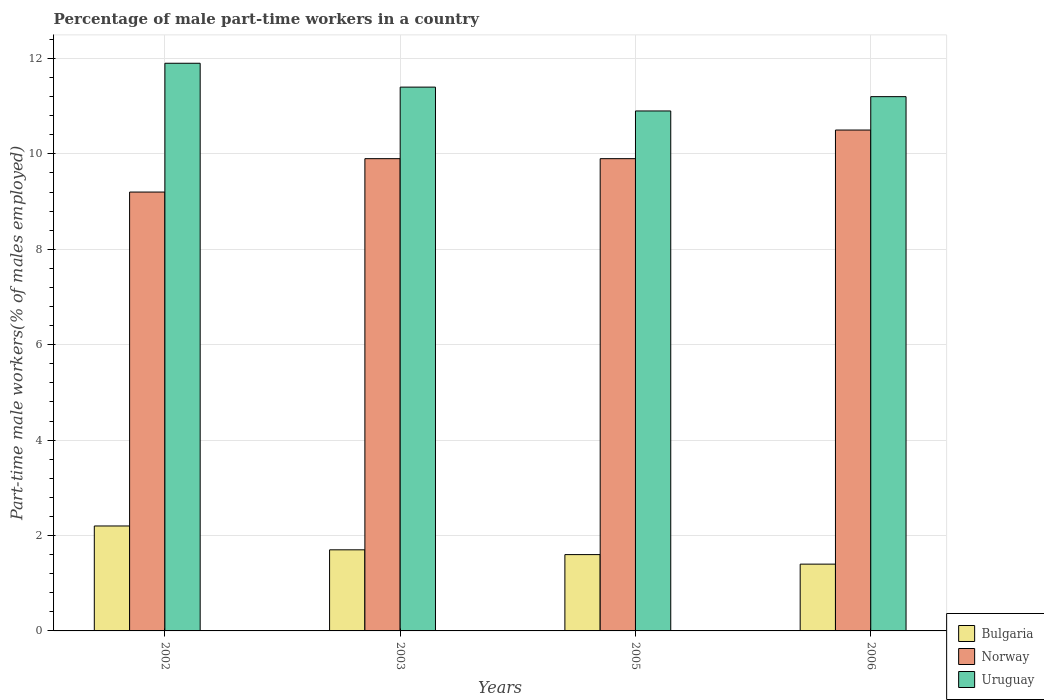Are the number of bars per tick equal to the number of legend labels?
Keep it short and to the point. Yes. Are the number of bars on each tick of the X-axis equal?
Offer a terse response. Yes. How many bars are there on the 4th tick from the left?
Ensure brevity in your answer.  3. What is the percentage of male part-time workers in Uruguay in 2002?
Give a very brief answer. 11.9. Across all years, what is the maximum percentage of male part-time workers in Uruguay?
Offer a very short reply. 11.9. Across all years, what is the minimum percentage of male part-time workers in Bulgaria?
Provide a short and direct response. 1.4. What is the total percentage of male part-time workers in Uruguay in the graph?
Your answer should be compact. 45.4. What is the difference between the percentage of male part-time workers in Norway in 2002 and that in 2003?
Provide a short and direct response. -0.7. What is the difference between the percentage of male part-time workers in Uruguay in 2003 and the percentage of male part-time workers in Norway in 2005?
Keep it short and to the point. 1.5. What is the average percentage of male part-time workers in Uruguay per year?
Give a very brief answer. 11.35. In the year 2003, what is the difference between the percentage of male part-time workers in Uruguay and percentage of male part-time workers in Norway?
Your answer should be compact. 1.5. What is the ratio of the percentage of male part-time workers in Uruguay in 2003 to that in 2006?
Your answer should be very brief. 1.02. Is the percentage of male part-time workers in Bulgaria in 2002 less than that in 2006?
Offer a very short reply. No. Is the difference between the percentage of male part-time workers in Uruguay in 2005 and 2006 greater than the difference between the percentage of male part-time workers in Norway in 2005 and 2006?
Provide a succinct answer. Yes. What is the difference between the highest and the lowest percentage of male part-time workers in Bulgaria?
Your answer should be compact. 0.8. Is the sum of the percentage of male part-time workers in Bulgaria in 2002 and 2006 greater than the maximum percentage of male part-time workers in Norway across all years?
Make the answer very short. No. What does the 3rd bar from the left in 2005 represents?
Make the answer very short. Uruguay. How many bars are there?
Keep it short and to the point. 12. How many years are there in the graph?
Give a very brief answer. 4. What is the difference between two consecutive major ticks on the Y-axis?
Give a very brief answer. 2. Are the values on the major ticks of Y-axis written in scientific E-notation?
Your response must be concise. No. Does the graph contain grids?
Your response must be concise. Yes. Where does the legend appear in the graph?
Your answer should be very brief. Bottom right. How many legend labels are there?
Offer a terse response. 3. What is the title of the graph?
Your answer should be very brief. Percentage of male part-time workers in a country. Does "Arab World" appear as one of the legend labels in the graph?
Make the answer very short. No. What is the label or title of the Y-axis?
Give a very brief answer. Part-time male workers(% of males employed). What is the Part-time male workers(% of males employed) of Bulgaria in 2002?
Provide a short and direct response. 2.2. What is the Part-time male workers(% of males employed) of Norway in 2002?
Offer a very short reply. 9.2. What is the Part-time male workers(% of males employed) of Uruguay in 2002?
Provide a short and direct response. 11.9. What is the Part-time male workers(% of males employed) in Bulgaria in 2003?
Make the answer very short. 1.7. What is the Part-time male workers(% of males employed) of Norway in 2003?
Your answer should be compact. 9.9. What is the Part-time male workers(% of males employed) of Uruguay in 2003?
Ensure brevity in your answer.  11.4. What is the Part-time male workers(% of males employed) in Bulgaria in 2005?
Give a very brief answer. 1.6. What is the Part-time male workers(% of males employed) in Norway in 2005?
Ensure brevity in your answer.  9.9. What is the Part-time male workers(% of males employed) in Uruguay in 2005?
Your response must be concise. 10.9. What is the Part-time male workers(% of males employed) of Bulgaria in 2006?
Ensure brevity in your answer.  1.4. What is the Part-time male workers(% of males employed) in Uruguay in 2006?
Ensure brevity in your answer.  11.2. Across all years, what is the maximum Part-time male workers(% of males employed) in Bulgaria?
Make the answer very short. 2.2. Across all years, what is the maximum Part-time male workers(% of males employed) of Uruguay?
Keep it short and to the point. 11.9. Across all years, what is the minimum Part-time male workers(% of males employed) of Bulgaria?
Your answer should be compact. 1.4. Across all years, what is the minimum Part-time male workers(% of males employed) of Norway?
Your answer should be compact. 9.2. Across all years, what is the minimum Part-time male workers(% of males employed) in Uruguay?
Provide a succinct answer. 10.9. What is the total Part-time male workers(% of males employed) in Bulgaria in the graph?
Offer a very short reply. 6.9. What is the total Part-time male workers(% of males employed) in Norway in the graph?
Ensure brevity in your answer.  39.5. What is the total Part-time male workers(% of males employed) of Uruguay in the graph?
Your response must be concise. 45.4. What is the difference between the Part-time male workers(% of males employed) of Bulgaria in 2002 and that in 2003?
Your answer should be very brief. 0.5. What is the difference between the Part-time male workers(% of males employed) of Norway in 2002 and that in 2003?
Your response must be concise. -0.7. What is the difference between the Part-time male workers(% of males employed) of Uruguay in 2002 and that in 2003?
Keep it short and to the point. 0.5. What is the difference between the Part-time male workers(% of males employed) in Bulgaria in 2002 and that in 2005?
Your answer should be very brief. 0.6. What is the difference between the Part-time male workers(% of males employed) of Norway in 2002 and that in 2005?
Give a very brief answer. -0.7. What is the difference between the Part-time male workers(% of males employed) of Uruguay in 2002 and that in 2005?
Offer a terse response. 1. What is the difference between the Part-time male workers(% of males employed) in Uruguay in 2002 and that in 2006?
Give a very brief answer. 0.7. What is the difference between the Part-time male workers(% of males employed) in Uruguay in 2003 and that in 2005?
Your answer should be compact. 0.5. What is the difference between the Part-time male workers(% of males employed) of Norway in 2003 and that in 2006?
Provide a short and direct response. -0.6. What is the difference between the Part-time male workers(% of males employed) in Uruguay in 2003 and that in 2006?
Give a very brief answer. 0.2. What is the difference between the Part-time male workers(% of males employed) in Bulgaria in 2005 and that in 2006?
Offer a terse response. 0.2. What is the difference between the Part-time male workers(% of males employed) in Uruguay in 2005 and that in 2006?
Your answer should be very brief. -0.3. What is the difference between the Part-time male workers(% of males employed) of Bulgaria in 2002 and the Part-time male workers(% of males employed) of Norway in 2005?
Your answer should be very brief. -7.7. What is the difference between the Part-time male workers(% of males employed) in Norway in 2002 and the Part-time male workers(% of males employed) in Uruguay in 2005?
Your answer should be compact. -1.7. What is the difference between the Part-time male workers(% of males employed) of Bulgaria in 2002 and the Part-time male workers(% of males employed) of Uruguay in 2006?
Make the answer very short. -9. What is the difference between the Part-time male workers(% of males employed) of Bulgaria in 2003 and the Part-time male workers(% of males employed) of Norway in 2005?
Give a very brief answer. -8.2. What is the difference between the Part-time male workers(% of males employed) in Norway in 2003 and the Part-time male workers(% of males employed) in Uruguay in 2005?
Provide a short and direct response. -1. What is the difference between the Part-time male workers(% of males employed) of Bulgaria in 2003 and the Part-time male workers(% of males employed) of Norway in 2006?
Provide a succinct answer. -8.8. What is the difference between the Part-time male workers(% of males employed) in Bulgaria in 2003 and the Part-time male workers(% of males employed) in Uruguay in 2006?
Ensure brevity in your answer.  -9.5. What is the difference between the Part-time male workers(% of males employed) in Bulgaria in 2005 and the Part-time male workers(% of males employed) in Uruguay in 2006?
Your response must be concise. -9.6. What is the difference between the Part-time male workers(% of males employed) in Norway in 2005 and the Part-time male workers(% of males employed) in Uruguay in 2006?
Offer a terse response. -1.3. What is the average Part-time male workers(% of males employed) in Bulgaria per year?
Provide a succinct answer. 1.73. What is the average Part-time male workers(% of males employed) of Norway per year?
Ensure brevity in your answer.  9.88. What is the average Part-time male workers(% of males employed) in Uruguay per year?
Offer a terse response. 11.35. In the year 2002, what is the difference between the Part-time male workers(% of males employed) of Bulgaria and Part-time male workers(% of males employed) of Uruguay?
Your response must be concise. -9.7. In the year 2003, what is the difference between the Part-time male workers(% of males employed) in Bulgaria and Part-time male workers(% of males employed) in Norway?
Your answer should be very brief. -8.2. In the year 2003, what is the difference between the Part-time male workers(% of males employed) in Bulgaria and Part-time male workers(% of males employed) in Uruguay?
Make the answer very short. -9.7. In the year 2005, what is the difference between the Part-time male workers(% of males employed) in Bulgaria and Part-time male workers(% of males employed) in Uruguay?
Make the answer very short. -9.3. In the year 2006, what is the difference between the Part-time male workers(% of males employed) in Bulgaria and Part-time male workers(% of males employed) in Norway?
Make the answer very short. -9.1. What is the ratio of the Part-time male workers(% of males employed) in Bulgaria in 2002 to that in 2003?
Your response must be concise. 1.29. What is the ratio of the Part-time male workers(% of males employed) in Norway in 2002 to that in 2003?
Your answer should be very brief. 0.93. What is the ratio of the Part-time male workers(% of males employed) of Uruguay in 2002 to that in 2003?
Give a very brief answer. 1.04. What is the ratio of the Part-time male workers(% of males employed) of Bulgaria in 2002 to that in 2005?
Give a very brief answer. 1.38. What is the ratio of the Part-time male workers(% of males employed) in Norway in 2002 to that in 2005?
Make the answer very short. 0.93. What is the ratio of the Part-time male workers(% of males employed) in Uruguay in 2002 to that in 2005?
Your answer should be very brief. 1.09. What is the ratio of the Part-time male workers(% of males employed) of Bulgaria in 2002 to that in 2006?
Offer a terse response. 1.57. What is the ratio of the Part-time male workers(% of males employed) of Norway in 2002 to that in 2006?
Offer a very short reply. 0.88. What is the ratio of the Part-time male workers(% of males employed) in Norway in 2003 to that in 2005?
Give a very brief answer. 1. What is the ratio of the Part-time male workers(% of males employed) in Uruguay in 2003 to that in 2005?
Offer a terse response. 1.05. What is the ratio of the Part-time male workers(% of males employed) of Bulgaria in 2003 to that in 2006?
Ensure brevity in your answer.  1.21. What is the ratio of the Part-time male workers(% of males employed) in Norway in 2003 to that in 2006?
Ensure brevity in your answer.  0.94. What is the ratio of the Part-time male workers(% of males employed) of Uruguay in 2003 to that in 2006?
Give a very brief answer. 1.02. What is the ratio of the Part-time male workers(% of males employed) of Bulgaria in 2005 to that in 2006?
Offer a very short reply. 1.14. What is the ratio of the Part-time male workers(% of males employed) in Norway in 2005 to that in 2006?
Offer a terse response. 0.94. What is the ratio of the Part-time male workers(% of males employed) in Uruguay in 2005 to that in 2006?
Make the answer very short. 0.97. What is the difference between the highest and the second highest Part-time male workers(% of males employed) of Uruguay?
Offer a very short reply. 0.5. What is the difference between the highest and the lowest Part-time male workers(% of males employed) in Norway?
Keep it short and to the point. 1.3. What is the difference between the highest and the lowest Part-time male workers(% of males employed) in Uruguay?
Offer a terse response. 1. 